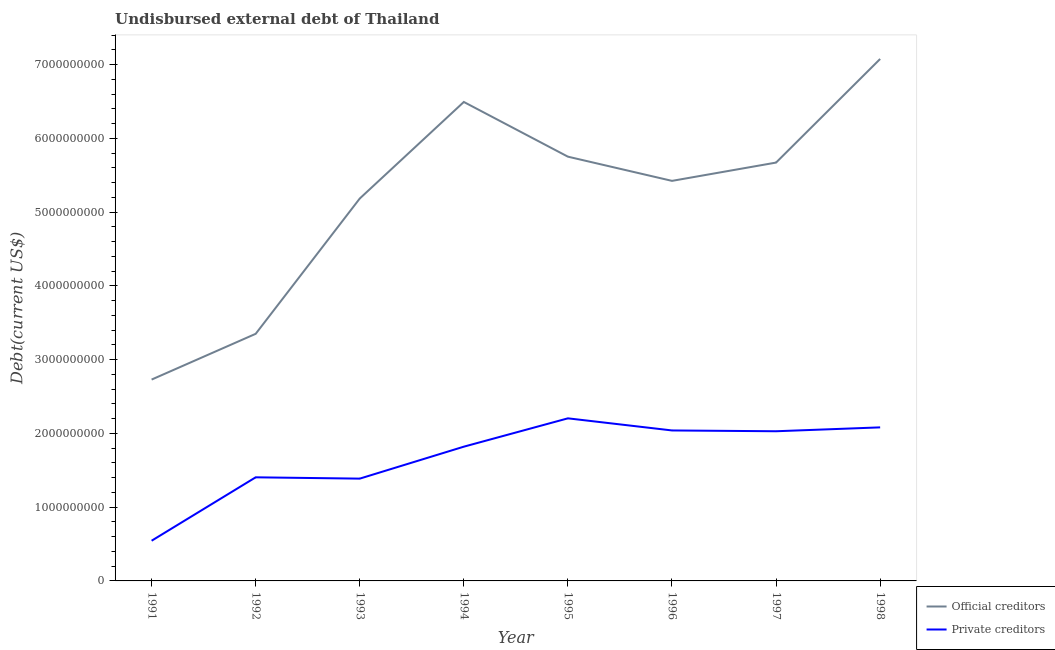How many different coloured lines are there?
Make the answer very short. 2. Does the line corresponding to undisbursed external debt of official creditors intersect with the line corresponding to undisbursed external debt of private creditors?
Your answer should be very brief. No. Is the number of lines equal to the number of legend labels?
Ensure brevity in your answer.  Yes. What is the undisbursed external debt of official creditors in 1993?
Ensure brevity in your answer.  5.18e+09. Across all years, what is the maximum undisbursed external debt of official creditors?
Your response must be concise. 7.08e+09. Across all years, what is the minimum undisbursed external debt of private creditors?
Make the answer very short. 5.45e+08. In which year was the undisbursed external debt of official creditors maximum?
Give a very brief answer. 1998. In which year was the undisbursed external debt of private creditors minimum?
Offer a very short reply. 1991. What is the total undisbursed external debt of private creditors in the graph?
Make the answer very short. 1.35e+1. What is the difference between the undisbursed external debt of private creditors in 1993 and that in 1997?
Make the answer very short. -6.42e+08. What is the difference between the undisbursed external debt of private creditors in 1997 and the undisbursed external debt of official creditors in 1998?
Keep it short and to the point. -5.05e+09. What is the average undisbursed external debt of private creditors per year?
Provide a short and direct response. 1.69e+09. In the year 1992, what is the difference between the undisbursed external debt of official creditors and undisbursed external debt of private creditors?
Provide a succinct answer. 1.95e+09. What is the ratio of the undisbursed external debt of official creditors in 1996 to that in 1998?
Offer a very short reply. 0.77. Is the undisbursed external debt of official creditors in 1994 less than that in 1995?
Provide a succinct answer. No. What is the difference between the highest and the second highest undisbursed external debt of private creditors?
Offer a very short reply. 1.23e+08. What is the difference between the highest and the lowest undisbursed external debt of private creditors?
Offer a very short reply. 1.66e+09. Is the sum of the undisbursed external debt of private creditors in 1992 and 1997 greater than the maximum undisbursed external debt of official creditors across all years?
Your response must be concise. No. Does the undisbursed external debt of official creditors monotonically increase over the years?
Offer a terse response. No. Is the undisbursed external debt of private creditors strictly greater than the undisbursed external debt of official creditors over the years?
Provide a succinct answer. No. How many lines are there?
Offer a terse response. 2. What is the difference between two consecutive major ticks on the Y-axis?
Ensure brevity in your answer.  1.00e+09. Are the values on the major ticks of Y-axis written in scientific E-notation?
Your answer should be compact. No. Where does the legend appear in the graph?
Your answer should be very brief. Bottom right. How are the legend labels stacked?
Your answer should be compact. Vertical. What is the title of the graph?
Your answer should be compact. Undisbursed external debt of Thailand. Does "Services" appear as one of the legend labels in the graph?
Give a very brief answer. No. What is the label or title of the Y-axis?
Your response must be concise. Debt(current US$). What is the Debt(current US$) in Official creditors in 1991?
Provide a succinct answer. 2.73e+09. What is the Debt(current US$) of Private creditors in 1991?
Provide a succinct answer. 5.45e+08. What is the Debt(current US$) in Official creditors in 1992?
Keep it short and to the point. 3.35e+09. What is the Debt(current US$) in Private creditors in 1992?
Ensure brevity in your answer.  1.40e+09. What is the Debt(current US$) of Official creditors in 1993?
Make the answer very short. 5.18e+09. What is the Debt(current US$) in Private creditors in 1993?
Your answer should be very brief. 1.39e+09. What is the Debt(current US$) in Official creditors in 1994?
Ensure brevity in your answer.  6.49e+09. What is the Debt(current US$) of Private creditors in 1994?
Provide a succinct answer. 1.82e+09. What is the Debt(current US$) of Official creditors in 1995?
Offer a terse response. 5.75e+09. What is the Debt(current US$) in Private creditors in 1995?
Make the answer very short. 2.20e+09. What is the Debt(current US$) in Official creditors in 1996?
Provide a succinct answer. 5.42e+09. What is the Debt(current US$) in Private creditors in 1996?
Offer a terse response. 2.04e+09. What is the Debt(current US$) in Official creditors in 1997?
Provide a succinct answer. 5.67e+09. What is the Debt(current US$) in Private creditors in 1997?
Give a very brief answer. 2.03e+09. What is the Debt(current US$) in Official creditors in 1998?
Provide a succinct answer. 7.08e+09. What is the Debt(current US$) of Private creditors in 1998?
Provide a short and direct response. 2.08e+09. Across all years, what is the maximum Debt(current US$) in Official creditors?
Keep it short and to the point. 7.08e+09. Across all years, what is the maximum Debt(current US$) in Private creditors?
Keep it short and to the point. 2.20e+09. Across all years, what is the minimum Debt(current US$) of Official creditors?
Your response must be concise. 2.73e+09. Across all years, what is the minimum Debt(current US$) in Private creditors?
Make the answer very short. 5.45e+08. What is the total Debt(current US$) of Official creditors in the graph?
Ensure brevity in your answer.  4.17e+1. What is the total Debt(current US$) in Private creditors in the graph?
Ensure brevity in your answer.  1.35e+1. What is the difference between the Debt(current US$) of Official creditors in 1991 and that in 1992?
Provide a succinct answer. -6.20e+08. What is the difference between the Debt(current US$) of Private creditors in 1991 and that in 1992?
Provide a short and direct response. -8.60e+08. What is the difference between the Debt(current US$) of Official creditors in 1991 and that in 1993?
Your answer should be very brief. -2.45e+09. What is the difference between the Debt(current US$) of Private creditors in 1991 and that in 1993?
Offer a terse response. -8.42e+08. What is the difference between the Debt(current US$) in Official creditors in 1991 and that in 1994?
Provide a succinct answer. -3.76e+09. What is the difference between the Debt(current US$) of Private creditors in 1991 and that in 1994?
Make the answer very short. -1.28e+09. What is the difference between the Debt(current US$) in Official creditors in 1991 and that in 1995?
Provide a short and direct response. -3.02e+09. What is the difference between the Debt(current US$) of Private creditors in 1991 and that in 1995?
Provide a succinct answer. -1.66e+09. What is the difference between the Debt(current US$) of Official creditors in 1991 and that in 1996?
Keep it short and to the point. -2.69e+09. What is the difference between the Debt(current US$) in Private creditors in 1991 and that in 1996?
Your answer should be very brief. -1.50e+09. What is the difference between the Debt(current US$) of Official creditors in 1991 and that in 1997?
Offer a terse response. -2.94e+09. What is the difference between the Debt(current US$) in Private creditors in 1991 and that in 1997?
Make the answer very short. -1.48e+09. What is the difference between the Debt(current US$) of Official creditors in 1991 and that in 1998?
Offer a very short reply. -4.35e+09. What is the difference between the Debt(current US$) in Private creditors in 1991 and that in 1998?
Your answer should be very brief. -1.54e+09. What is the difference between the Debt(current US$) of Official creditors in 1992 and that in 1993?
Provide a succinct answer. -1.83e+09. What is the difference between the Debt(current US$) in Private creditors in 1992 and that in 1993?
Provide a succinct answer. 1.78e+07. What is the difference between the Debt(current US$) of Official creditors in 1992 and that in 1994?
Offer a terse response. -3.14e+09. What is the difference between the Debt(current US$) in Private creditors in 1992 and that in 1994?
Give a very brief answer. -4.15e+08. What is the difference between the Debt(current US$) in Official creditors in 1992 and that in 1995?
Ensure brevity in your answer.  -2.40e+09. What is the difference between the Debt(current US$) of Private creditors in 1992 and that in 1995?
Your answer should be compact. -8.00e+08. What is the difference between the Debt(current US$) of Official creditors in 1992 and that in 1996?
Your response must be concise. -2.07e+09. What is the difference between the Debt(current US$) in Private creditors in 1992 and that in 1996?
Provide a short and direct response. -6.35e+08. What is the difference between the Debt(current US$) of Official creditors in 1992 and that in 1997?
Provide a short and direct response. -2.32e+09. What is the difference between the Debt(current US$) in Private creditors in 1992 and that in 1997?
Your response must be concise. -6.25e+08. What is the difference between the Debt(current US$) of Official creditors in 1992 and that in 1998?
Make the answer very short. -3.73e+09. What is the difference between the Debt(current US$) of Private creditors in 1992 and that in 1998?
Provide a short and direct response. -6.77e+08. What is the difference between the Debt(current US$) of Official creditors in 1993 and that in 1994?
Provide a short and direct response. -1.31e+09. What is the difference between the Debt(current US$) of Private creditors in 1993 and that in 1994?
Your response must be concise. -4.33e+08. What is the difference between the Debt(current US$) in Official creditors in 1993 and that in 1995?
Provide a succinct answer. -5.67e+08. What is the difference between the Debt(current US$) in Private creditors in 1993 and that in 1995?
Make the answer very short. -8.17e+08. What is the difference between the Debt(current US$) of Official creditors in 1993 and that in 1996?
Keep it short and to the point. -2.39e+08. What is the difference between the Debt(current US$) of Private creditors in 1993 and that in 1996?
Offer a terse response. -6.53e+08. What is the difference between the Debt(current US$) of Official creditors in 1993 and that in 1997?
Give a very brief answer. -4.87e+08. What is the difference between the Debt(current US$) in Private creditors in 1993 and that in 1997?
Give a very brief answer. -6.42e+08. What is the difference between the Debt(current US$) in Official creditors in 1993 and that in 1998?
Your answer should be very brief. -1.89e+09. What is the difference between the Debt(current US$) in Private creditors in 1993 and that in 1998?
Your response must be concise. -6.95e+08. What is the difference between the Debt(current US$) in Official creditors in 1994 and that in 1995?
Your answer should be very brief. 7.42e+08. What is the difference between the Debt(current US$) of Private creditors in 1994 and that in 1995?
Offer a very short reply. -3.84e+08. What is the difference between the Debt(current US$) in Official creditors in 1994 and that in 1996?
Provide a short and direct response. 1.07e+09. What is the difference between the Debt(current US$) of Private creditors in 1994 and that in 1996?
Make the answer very short. -2.20e+08. What is the difference between the Debt(current US$) of Official creditors in 1994 and that in 1997?
Your answer should be very brief. 8.22e+08. What is the difference between the Debt(current US$) in Private creditors in 1994 and that in 1997?
Offer a terse response. -2.09e+08. What is the difference between the Debt(current US$) of Official creditors in 1994 and that in 1998?
Your answer should be compact. -5.83e+08. What is the difference between the Debt(current US$) of Private creditors in 1994 and that in 1998?
Ensure brevity in your answer.  -2.62e+08. What is the difference between the Debt(current US$) in Official creditors in 1995 and that in 1996?
Your answer should be compact. 3.28e+08. What is the difference between the Debt(current US$) in Private creditors in 1995 and that in 1996?
Provide a succinct answer. 1.64e+08. What is the difference between the Debt(current US$) of Official creditors in 1995 and that in 1997?
Give a very brief answer. 8.01e+07. What is the difference between the Debt(current US$) of Private creditors in 1995 and that in 1997?
Ensure brevity in your answer.  1.75e+08. What is the difference between the Debt(current US$) in Official creditors in 1995 and that in 1998?
Offer a terse response. -1.32e+09. What is the difference between the Debt(current US$) of Private creditors in 1995 and that in 1998?
Keep it short and to the point. 1.23e+08. What is the difference between the Debt(current US$) in Official creditors in 1996 and that in 1997?
Offer a very short reply. -2.48e+08. What is the difference between the Debt(current US$) in Private creditors in 1996 and that in 1997?
Your answer should be compact. 1.09e+07. What is the difference between the Debt(current US$) in Official creditors in 1996 and that in 1998?
Provide a short and direct response. -1.65e+09. What is the difference between the Debt(current US$) of Private creditors in 1996 and that in 1998?
Make the answer very short. -4.16e+07. What is the difference between the Debt(current US$) in Official creditors in 1997 and that in 1998?
Make the answer very short. -1.40e+09. What is the difference between the Debt(current US$) in Private creditors in 1997 and that in 1998?
Provide a short and direct response. -5.25e+07. What is the difference between the Debt(current US$) of Official creditors in 1991 and the Debt(current US$) of Private creditors in 1992?
Your answer should be very brief. 1.33e+09. What is the difference between the Debt(current US$) of Official creditors in 1991 and the Debt(current US$) of Private creditors in 1993?
Give a very brief answer. 1.34e+09. What is the difference between the Debt(current US$) of Official creditors in 1991 and the Debt(current US$) of Private creditors in 1994?
Give a very brief answer. 9.10e+08. What is the difference between the Debt(current US$) of Official creditors in 1991 and the Debt(current US$) of Private creditors in 1995?
Offer a very short reply. 5.26e+08. What is the difference between the Debt(current US$) in Official creditors in 1991 and the Debt(current US$) in Private creditors in 1996?
Provide a short and direct response. 6.90e+08. What is the difference between the Debt(current US$) of Official creditors in 1991 and the Debt(current US$) of Private creditors in 1997?
Provide a short and direct response. 7.01e+08. What is the difference between the Debt(current US$) of Official creditors in 1991 and the Debt(current US$) of Private creditors in 1998?
Offer a terse response. 6.48e+08. What is the difference between the Debt(current US$) of Official creditors in 1992 and the Debt(current US$) of Private creditors in 1993?
Provide a short and direct response. 1.96e+09. What is the difference between the Debt(current US$) of Official creditors in 1992 and the Debt(current US$) of Private creditors in 1994?
Provide a short and direct response. 1.53e+09. What is the difference between the Debt(current US$) in Official creditors in 1992 and the Debt(current US$) in Private creditors in 1995?
Give a very brief answer. 1.15e+09. What is the difference between the Debt(current US$) in Official creditors in 1992 and the Debt(current US$) in Private creditors in 1996?
Your answer should be very brief. 1.31e+09. What is the difference between the Debt(current US$) in Official creditors in 1992 and the Debt(current US$) in Private creditors in 1997?
Offer a terse response. 1.32e+09. What is the difference between the Debt(current US$) in Official creditors in 1992 and the Debt(current US$) in Private creditors in 1998?
Provide a succinct answer. 1.27e+09. What is the difference between the Debt(current US$) in Official creditors in 1993 and the Debt(current US$) in Private creditors in 1994?
Your answer should be very brief. 3.36e+09. What is the difference between the Debt(current US$) in Official creditors in 1993 and the Debt(current US$) in Private creditors in 1995?
Give a very brief answer. 2.98e+09. What is the difference between the Debt(current US$) of Official creditors in 1993 and the Debt(current US$) of Private creditors in 1996?
Provide a succinct answer. 3.14e+09. What is the difference between the Debt(current US$) in Official creditors in 1993 and the Debt(current US$) in Private creditors in 1997?
Your answer should be very brief. 3.16e+09. What is the difference between the Debt(current US$) in Official creditors in 1993 and the Debt(current US$) in Private creditors in 1998?
Offer a very short reply. 3.10e+09. What is the difference between the Debt(current US$) in Official creditors in 1994 and the Debt(current US$) in Private creditors in 1995?
Offer a very short reply. 4.29e+09. What is the difference between the Debt(current US$) in Official creditors in 1994 and the Debt(current US$) in Private creditors in 1996?
Offer a very short reply. 4.45e+09. What is the difference between the Debt(current US$) in Official creditors in 1994 and the Debt(current US$) in Private creditors in 1997?
Make the answer very short. 4.46e+09. What is the difference between the Debt(current US$) of Official creditors in 1994 and the Debt(current US$) of Private creditors in 1998?
Offer a very short reply. 4.41e+09. What is the difference between the Debt(current US$) in Official creditors in 1995 and the Debt(current US$) in Private creditors in 1996?
Offer a terse response. 3.71e+09. What is the difference between the Debt(current US$) in Official creditors in 1995 and the Debt(current US$) in Private creditors in 1997?
Provide a short and direct response. 3.72e+09. What is the difference between the Debt(current US$) in Official creditors in 1995 and the Debt(current US$) in Private creditors in 1998?
Keep it short and to the point. 3.67e+09. What is the difference between the Debt(current US$) of Official creditors in 1996 and the Debt(current US$) of Private creditors in 1997?
Provide a short and direct response. 3.39e+09. What is the difference between the Debt(current US$) in Official creditors in 1996 and the Debt(current US$) in Private creditors in 1998?
Your answer should be very brief. 3.34e+09. What is the difference between the Debt(current US$) in Official creditors in 1997 and the Debt(current US$) in Private creditors in 1998?
Keep it short and to the point. 3.59e+09. What is the average Debt(current US$) in Official creditors per year?
Offer a very short reply. 5.21e+09. What is the average Debt(current US$) in Private creditors per year?
Make the answer very short. 1.69e+09. In the year 1991, what is the difference between the Debt(current US$) of Official creditors and Debt(current US$) of Private creditors?
Ensure brevity in your answer.  2.18e+09. In the year 1992, what is the difference between the Debt(current US$) in Official creditors and Debt(current US$) in Private creditors?
Your response must be concise. 1.95e+09. In the year 1993, what is the difference between the Debt(current US$) in Official creditors and Debt(current US$) in Private creditors?
Ensure brevity in your answer.  3.80e+09. In the year 1994, what is the difference between the Debt(current US$) in Official creditors and Debt(current US$) in Private creditors?
Offer a very short reply. 4.67e+09. In the year 1995, what is the difference between the Debt(current US$) of Official creditors and Debt(current US$) of Private creditors?
Your answer should be very brief. 3.55e+09. In the year 1996, what is the difference between the Debt(current US$) in Official creditors and Debt(current US$) in Private creditors?
Provide a succinct answer. 3.38e+09. In the year 1997, what is the difference between the Debt(current US$) of Official creditors and Debt(current US$) of Private creditors?
Make the answer very short. 3.64e+09. In the year 1998, what is the difference between the Debt(current US$) in Official creditors and Debt(current US$) in Private creditors?
Offer a terse response. 4.99e+09. What is the ratio of the Debt(current US$) in Official creditors in 1991 to that in 1992?
Your response must be concise. 0.81. What is the ratio of the Debt(current US$) of Private creditors in 1991 to that in 1992?
Offer a very short reply. 0.39. What is the ratio of the Debt(current US$) of Official creditors in 1991 to that in 1993?
Provide a short and direct response. 0.53. What is the ratio of the Debt(current US$) of Private creditors in 1991 to that in 1993?
Ensure brevity in your answer.  0.39. What is the ratio of the Debt(current US$) in Official creditors in 1991 to that in 1994?
Provide a short and direct response. 0.42. What is the ratio of the Debt(current US$) in Private creditors in 1991 to that in 1994?
Provide a succinct answer. 0.3. What is the ratio of the Debt(current US$) of Official creditors in 1991 to that in 1995?
Your answer should be very brief. 0.47. What is the ratio of the Debt(current US$) of Private creditors in 1991 to that in 1995?
Ensure brevity in your answer.  0.25. What is the ratio of the Debt(current US$) of Official creditors in 1991 to that in 1996?
Provide a succinct answer. 0.5. What is the ratio of the Debt(current US$) in Private creditors in 1991 to that in 1996?
Offer a terse response. 0.27. What is the ratio of the Debt(current US$) in Official creditors in 1991 to that in 1997?
Your response must be concise. 0.48. What is the ratio of the Debt(current US$) in Private creditors in 1991 to that in 1997?
Make the answer very short. 0.27. What is the ratio of the Debt(current US$) in Official creditors in 1991 to that in 1998?
Your answer should be compact. 0.39. What is the ratio of the Debt(current US$) of Private creditors in 1991 to that in 1998?
Make the answer very short. 0.26. What is the ratio of the Debt(current US$) in Official creditors in 1992 to that in 1993?
Ensure brevity in your answer.  0.65. What is the ratio of the Debt(current US$) in Private creditors in 1992 to that in 1993?
Offer a very short reply. 1.01. What is the ratio of the Debt(current US$) of Official creditors in 1992 to that in 1994?
Provide a short and direct response. 0.52. What is the ratio of the Debt(current US$) of Private creditors in 1992 to that in 1994?
Offer a terse response. 0.77. What is the ratio of the Debt(current US$) of Official creditors in 1992 to that in 1995?
Give a very brief answer. 0.58. What is the ratio of the Debt(current US$) in Private creditors in 1992 to that in 1995?
Provide a short and direct response. 0.64. What is the ratio of the Debt(current US$) of Official creditors in 1992 to that in 1996?
Give a very brief answer. 0.62. What is the ratio of the Debt(current US$) of Private creditors in 1992 to that in 1996?
Your answer should be compact. 0.69. What is the ratio of the Debt(current US$) in Official creditors in 1992 to that in 1997?
Provide a succinct answer. 0.59. What is the ratio of the Debt(current US$) in Private creditors in 1992 to that in 1997?
Give a very brief answer. 0.69. What is the ratio of the Debt(current US$) in Official creditors in 1992 to that in 1998?
Ensure brevity in your answer.  0.47. What is the ratio of the Debt(current US$) in Private creditors in 1992 to that in 1998?
Make the answer very short. 0.67. What is the ratio of the Debt(current US$) of Official creditors in 1993 to that in 1994?
Give a very brief answer. 0.8. What is the ratio of the Debt(current US$) of Private creditors in 1993 to that in 1994?
Your answer should be very brief. 0.76. What is the ratio of the Debt(current US$) of Official creditors in 1993 to that in 1995?
Make the answer very short. 0.9. What is the ratio of the Debt(current US$) in Private creditors in 1993 to that in 1995?
Your answer should be compact. 0.63. What is the ratio of the Debt(current US$) in Official creditors in 1993 to that in 1996?
Offer a terse response. 0.96. What is the ratio of the Debt(current US$) of Private creditors in 1993 to that in 1996?
Your response must be concise. 0.68. What is the ratio of the Debt(current US$) of Official creditors in 1993 to that in 1997?
Provide a short and direct response. 0.91. What is the ratio of the Debt(current US$) in Private creditors in 1993 to that in 1997?
Provide a succinct answer. 0.68. What is the ratio of the Debt(current US$) of Official creditors in 1993 to that in 1998?
Provide a succinct answer. 0.73. What is the ratio of the Debt(current US$) of Private creditors in 1993 to that in 1998?
Keep it short and to the point. 0.67. What is the ratio of the Debt(current US$) of Official creditors in 1994 to that in 1995?
Offer a terse response. 1.13. What is the ratio of the Debt(current US$) in Private creditors in 1994 to that in 1995?
Your answer should be compact. 0.83. What is the ratio of the Debt(current US$) in Official creditors in 1994 to that in 1996?
Ensure brevity in your answer.  1.2. What is the ratio of the Debt(current US$) in Private creditors in 1994 to that in 1996?
Your answer should be very brief. 0.89. What is the ratio of the Debt(current US$) of Official creditors in 1994 to that in 1997?
Your answer should be very brief. 1.14. What is the ratio of the Debt(current US$) of Private creditors in 1994 to that in 1997?
Give a very brief answer. 0.9. What is the ratio of the Debt(current US$) in Official creditors in 1994 to that in 1998?
Your response must be concise. 0.92. What is the ratio of the Debt(current US$) in Private creditors in 1994 to that in 1998?
Your answer should be compact. 0.87. What is the ratio of the Debt(current US$) of Official creditors in 1995 to that in 1996?
Your response must be concise. 1.06. What is the ratio of the Debt(current US$) of Private creditors in 1995 to that in 1996?
Offer a very short reply. 1.08. What is the ratio of the Debt(current US$) in Official creditors in 1995 to that in 1997?
Your answer should be compact. 1.01. What is the ratio of the Debt(current US$) of Private creditors in 1995 to that in 1997?
Provide a succinct answer. 1.09. What is the ratio of the Debt(current US$) in Official creditors in 1995 to that in 1998?
Provide a succinct answer. 0.81. What is the ratio of the Debt(current US$) in Private creditors in 1995 to that in 1998?
Offer a very short reply. 1.06. What is the ratio of the Debt(current US$) of Official creditors in 1996 to that in 1997?
Ensure brevity in your answer.  0.96. What is the ratio of the Debt(current US$) in Private creditors in 1996 to that in 1997?
Keep it short and to the point. 1.01. What is the ratio of the Debt(current US$) of Official creditors in 1996 to that in 1998?
Ensure brevity in your answer.  0.77. What is the ratio of the Debt(current US$) of Official creditors in 1997 to that in 1998?
Provide a succinct answer. 0.8. What is the ratio of the Debt(current US$) in Private creditors in 1997 to that in 1998?
Provide a short and direct response. 0.97. What is the difference between the highest and the second highest Debt(current US$) of Official creditors?
Offer a very short reply. 5.83e+08. What is the difference between the highest and the second highest Debt(current US$) of Private creditors?
Provide a succinct answer. 1.23e+08. What is the difference between the highest and the lowest Debt(current US$) of Official creditors?
Keep it short and to the point. 4.35e+09. What is the difference between the highest and the lowest Debt(current US$) of Private creditors?
Your answer should be compact. 1.66e+09. 